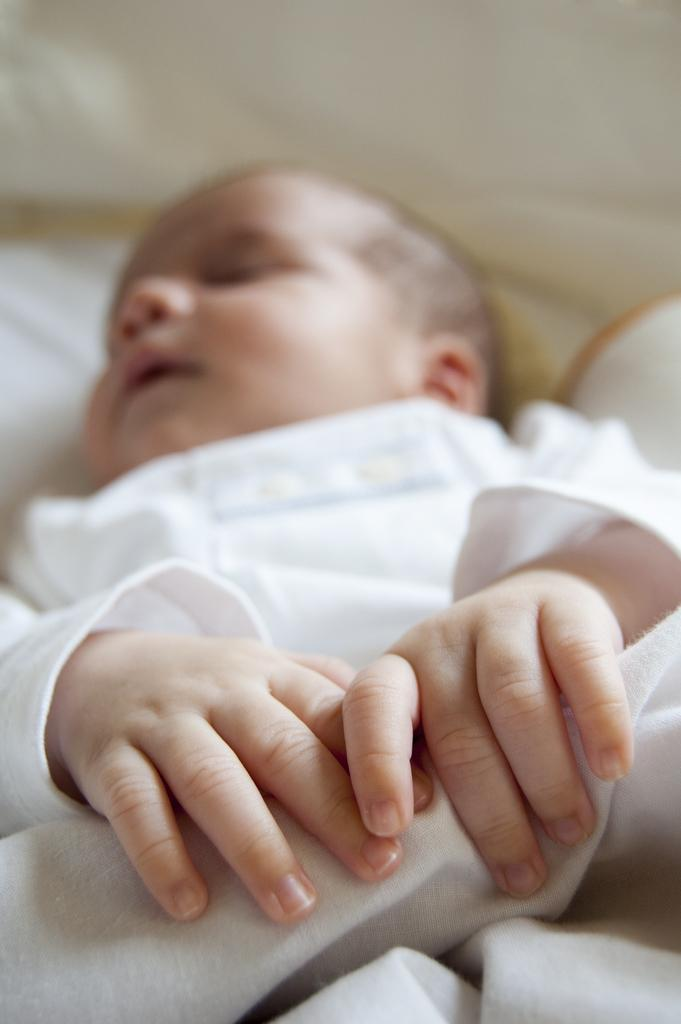What is the main subject of the image? The main subject of the image is a baby. What is the baby wearing in the image? The baby is wearing a white dress. Can you describe the background of the image? The background of the image is blurred. How many cherries can be seen in the baby's hand in the image? There are no cherries present in the image. What type of need is being used by the baby in the image? There is no need present in the image. What is the mass of the baby in the image? The mass of the baby cannot be determined from the image alone. 